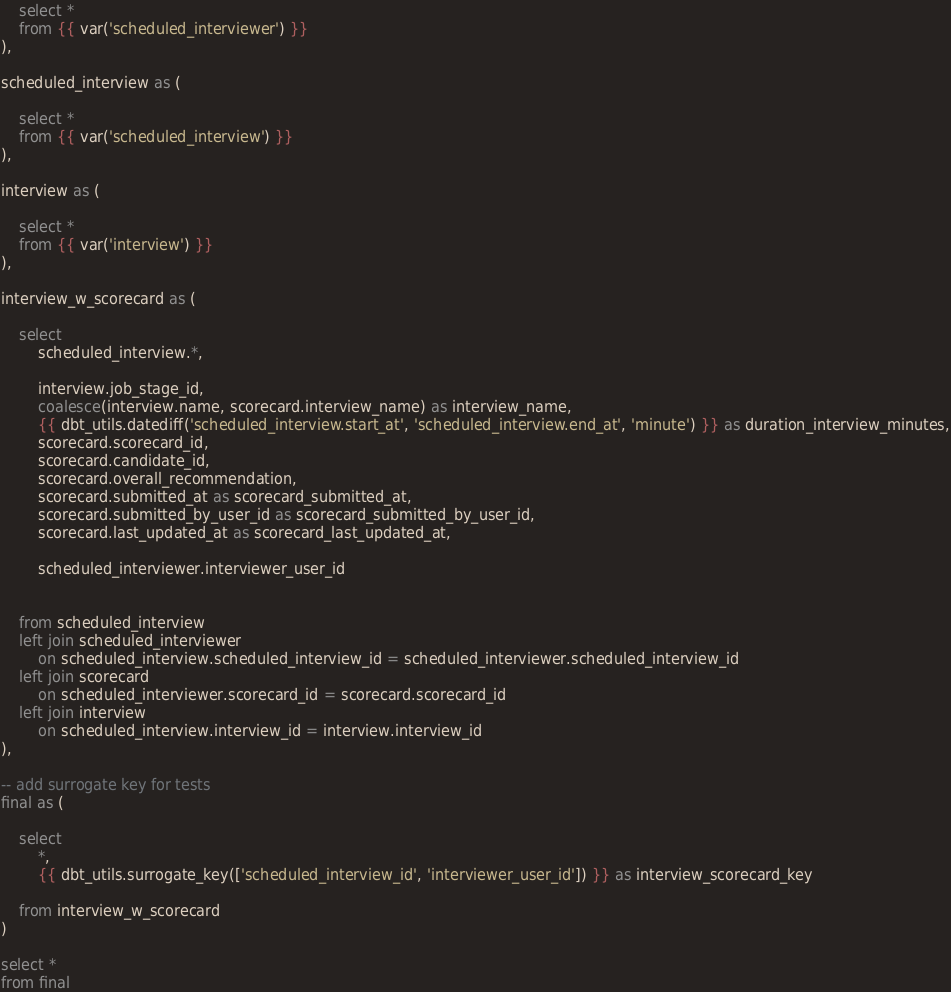<code> <loc_0><loc_0><loc_500><loc_500><_SQL_>    select *
    from {{ var('scheduled_interviewer') }}
),

scheduled_interview as (

    select *
    from {{ var('scheduled_interview') }}
),

interview as (
    
    select *
    from {{ var('interview') }}
),

interview_w_scorecard as (

    select
        scheduled_interview.*,

        interview.job_stage_id,
        coalesce(interview.name, scorecard.interview_name) as interview_name,
        {{ dbt_utils.datediff('scheduled_interview.start_at', 'scheduled_interview.end_at', 'minute') }} as duration_interview_minutes,
        scorecard.scorecard_id,
        scorecard.candidate_id,
        scorecard.overall_recommendation,
        scorecard.submitted_at as scorecard_submitted_at,
        scorecard.submitted_by_user_id as scorecard_submitted_by_user_id,
        scorecard.last_updated_at as scorecard_last_updated_at,

        scheduled_interviewer.interviewer_user_id
        

    from scheduled_interview
    left join scheduled_interviewer 
        on scheduled_interview.scheduled_interview_id = scheduled_interviewer.scheduled_interview_id
    left join scorecard
        on scheduled_interviewer.scorecard_id = scorecard.scorecard_id
    left join interview 
        on scheduled_interview.interview_id = interview.interview_id
),

-- add surrogate key for tests
final as (

    select
        *,
        {{ dbt_utils.surrogate_key(['scheduled_interview_id', 'interviewer_user_id']) }} as interview_scorecard_key
    
    from interview_w_scorecard
)

select *
from final</code> 